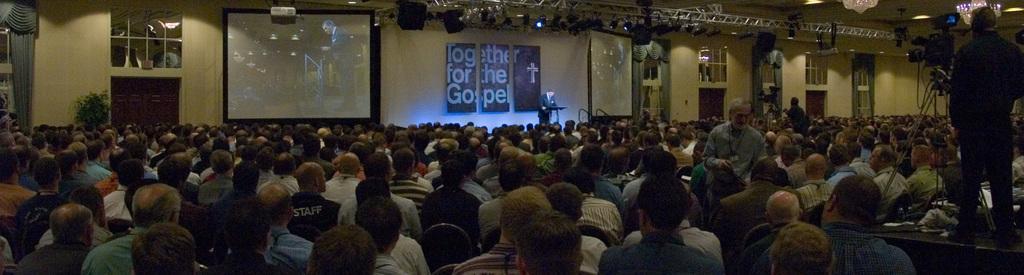Can you describe this image briefly? In this image we can see a group of people sitting on chairs, some people are standing and cameras are placed on stands. In the center of the image we can see screens, boards with text and a podium. In the background, we can see a plant, windows, curtains. At the top of the image we can see some lights on metal frames, speakers and some devices, we can also see some chandeliers. 